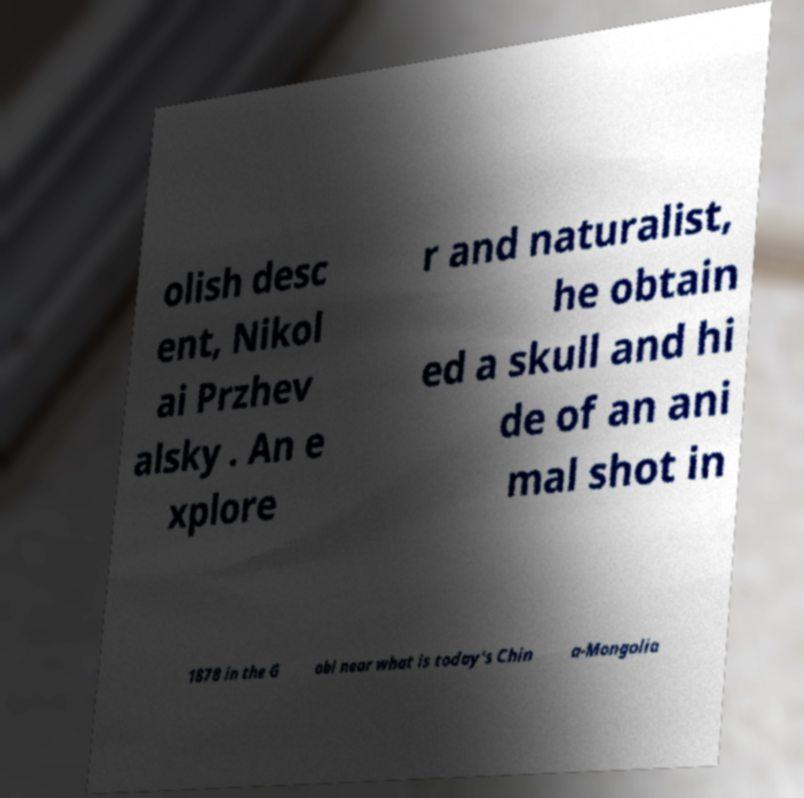There's text embedded in this image that I need extracted. Can you transcribe it verbatim? olish desc ent, Nikol ai Przhev alsky . An e xplore r and naturalist, he obtain ed a skull and hi de of an ani mal shot in 1878 in the G obi near what is today's Chin a-Mongolia 